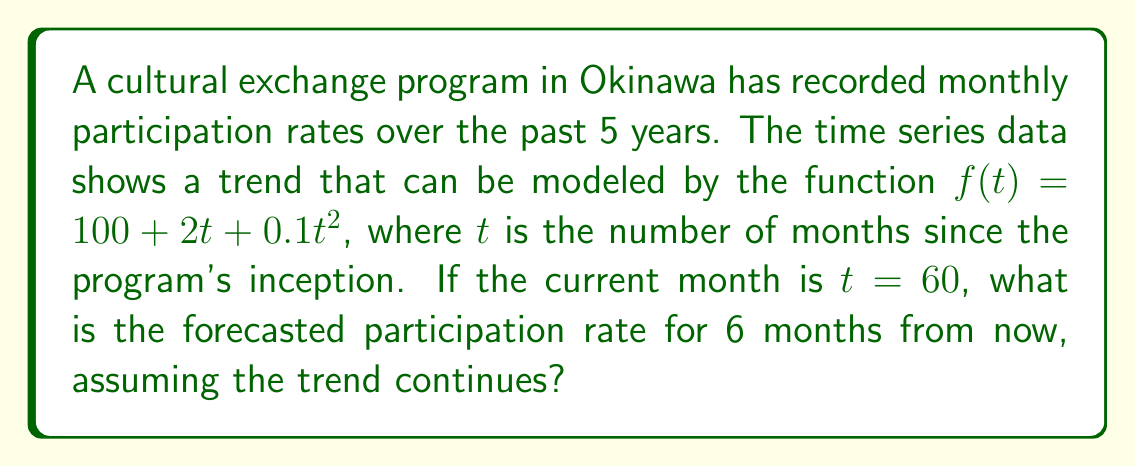Show me your answer to this math problem. To solve this problem, we'll follow these steps:

1) We are given the time series model:
   $$f(t) = 100 + 2t + 0.1t^2$$

2) We need to forecast 6 months into the future. The current month is $t = 60$, so we need to calculate for $t = 66$.

3) Let's substitute $t = 66$ into our model:

   $$f(66) = 100 + 2(66) + 0.1(66)^2$$

4) Let's calculate each term:
   - $100$ remains as is
   - $2(66) = 132$
   - $0.1(66)^2 = 0.1 * 4356 = 435.6$

5) Now, let's sum these terms:

   $$f(66) = 100 + 132 + 435.6 = 667.6$$

6) Therefore, the forecasted participation rate for 6 months from now is 667.6.
Answer: 667.6 